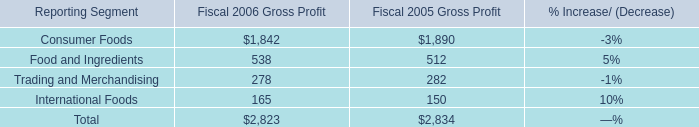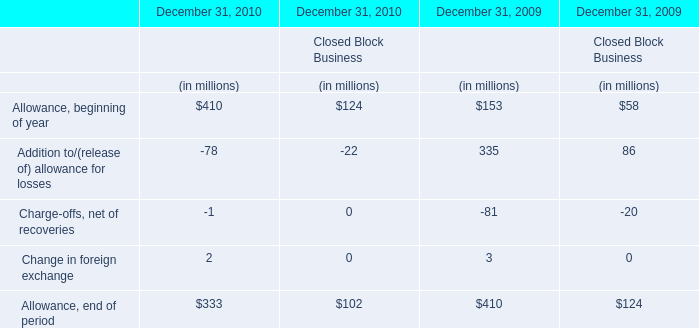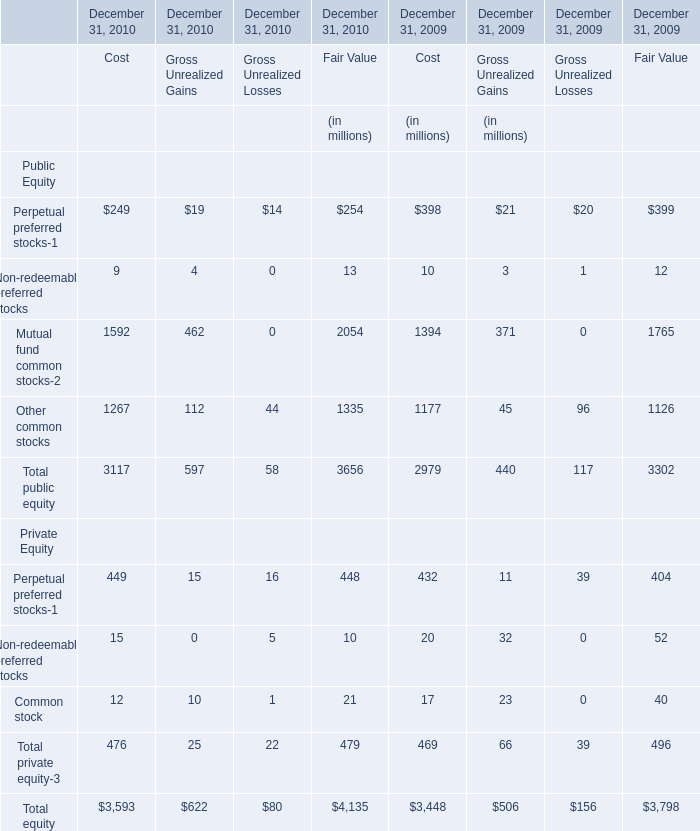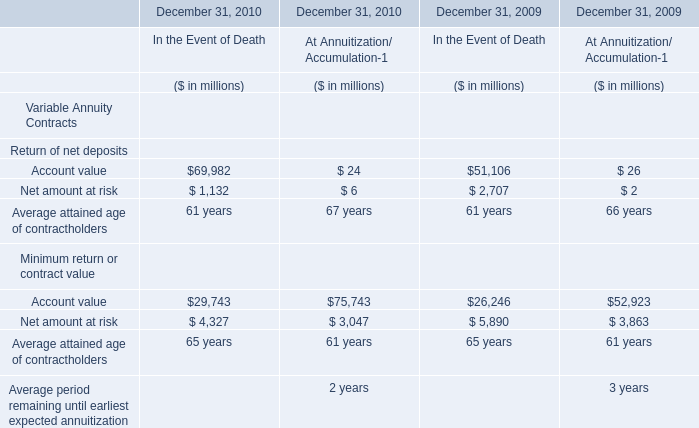What's the Gross Unrealized Gains for Total public equity at December 31, 2009? (in million) 
Answer: 440. 